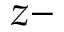Convert formula to latex. <formula><loc_0><loc_0><loc_500><loc_500>z -</formula> 